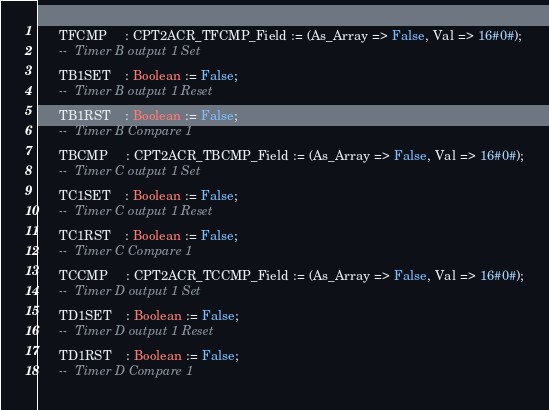<code> <loc_0><loc_0><loc_500><loc_500><_Ada_>      TFCMP     : CPT2ACR_TFCMP_Field := (As_Array => False, Val => 16#0#);
      --  Timer B output 1 Set
      TB1SET    : Boolean := False;
      --  Timer B output 1 Reset
      TB1RST    : Boolean := False;
      --  Timer B Compare 1
      TBCMP     : CPT2ACR_TBCMP_Field := (As_Array => False, Val => 16#0#);
      --  Timer C output 1 Set
      TC1SET    : Boolean := False;
      --  Timer C output 1 Reset
      TC1RST    : Boolean := False;
      --  Timer C Compare 1
      TCCMP     : CPT2ACR_TCCMP_Field := (As_Array => False, Val => 16#0#);
      --  Timer D output 1 Set
      TD1SET    : Boolean := False;
      --  Timer D output 1 Reset
      TD1RST    : Boolean := False;
      --  Timer D Compare 1</code> 